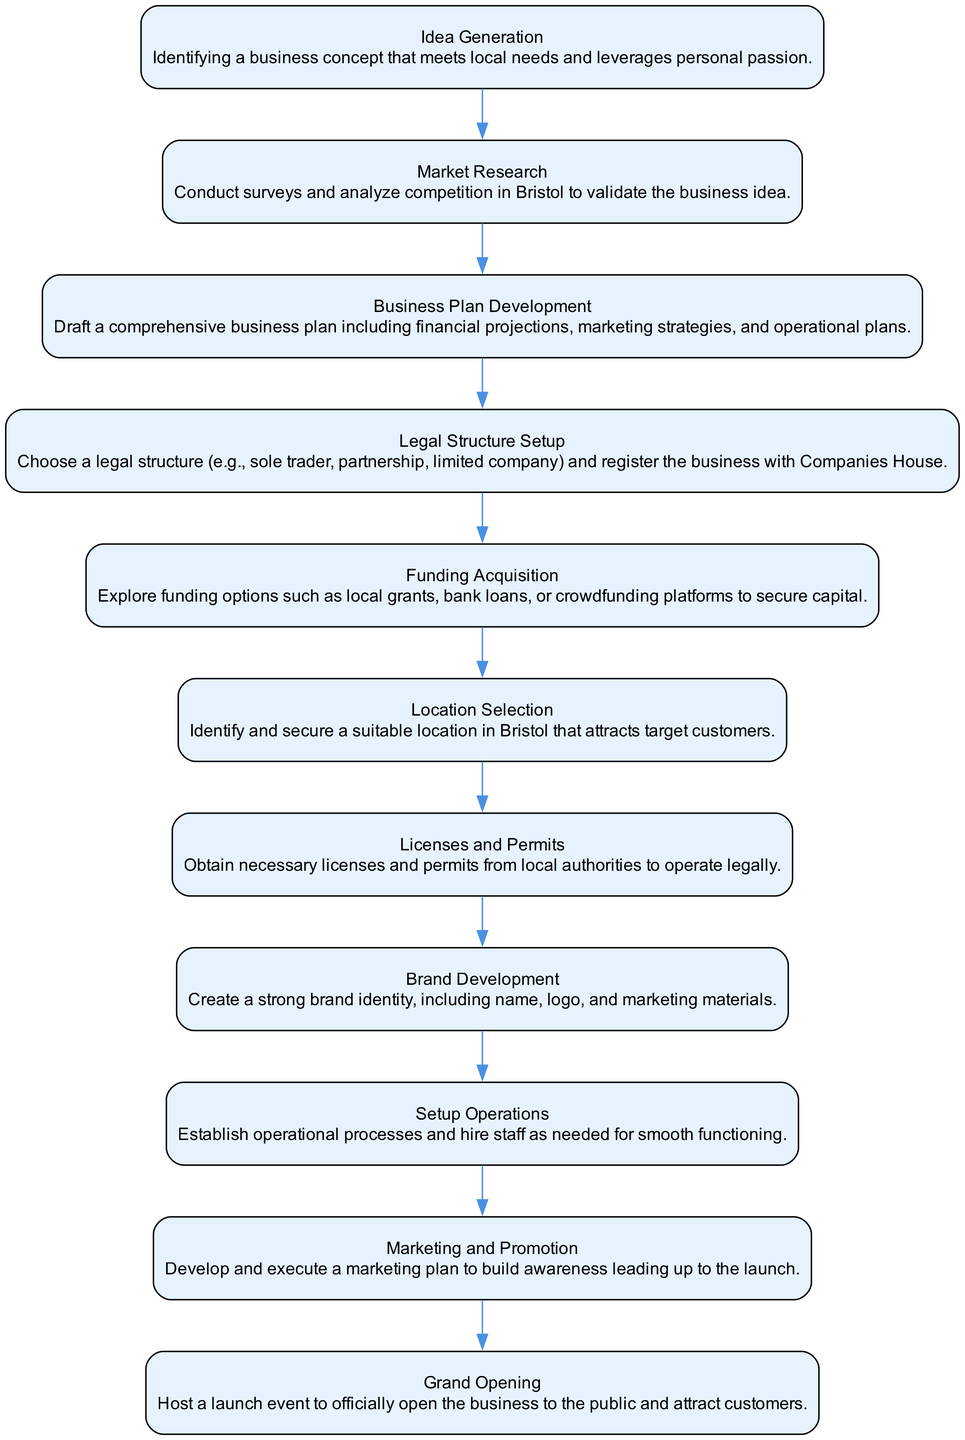What is the first step in the process? The first step in the diagram is "Idea Generation." This is seen at the top of the flow chart, indicating the starting point of the business launch process.
Answer: Idea Generation How many steps are there in total? Counting each step in the diagram, there are eleven distinct steps defined in the process, from "Idea Generation" to "Grand Opening."
Answer: 11 What step follows "Market Research"? The step following "Market Research" is "Business Plan Development." This is determined by tracing the flow from "Market Research" to the next node in the chart.
Answer: Business Plan Development Which step is directly before "Grand Opening"? The step directly before "Grand Opening" is "Marketing and Promotion." This can be concluded by moving step-by-step backward from "Grand Opening" to its predecessor.
Answer: Marketing and Promotion What is the last step in the process? The last step in the process is "Grand Opening." It appears at the bottom of the flow chart, signifying the completion of the business launch steps.
Answer: Grand Opening How many steps must be completed before selecting a location? Before selecting a location, seven steps must be completed: Idea Generation, Market Research, Business Plan Development, Legal Structure Setup, Funding Acquisition, and Licenses and Permits. This is found by counting the steps leading up to "Location Selection."
Answer: 6 What is needed to legally operate a business in Bristol? To legally operate a business in Bristol, it is necessary to obtain licenses and permits from local authorities. This is indicated as a specific step in the flow chart between "Location Selection" and "Brand Development."
Answer: Licenses and Permits Which step involves creating a brand identity? The step that involves creating a brand identity is "Brand Development." In the diagram, this is clearly labeled and follows the step of acquiring necessary licenses and permits.
Answer: Brand Development What is the main focus during "Funding Acquisition"? The main focus during "Funding Acquisition" is to explore funding options. This step explicitly states the need to investigate various financial sources, as depicted in the flow chart.
Answer: Explore funding options 